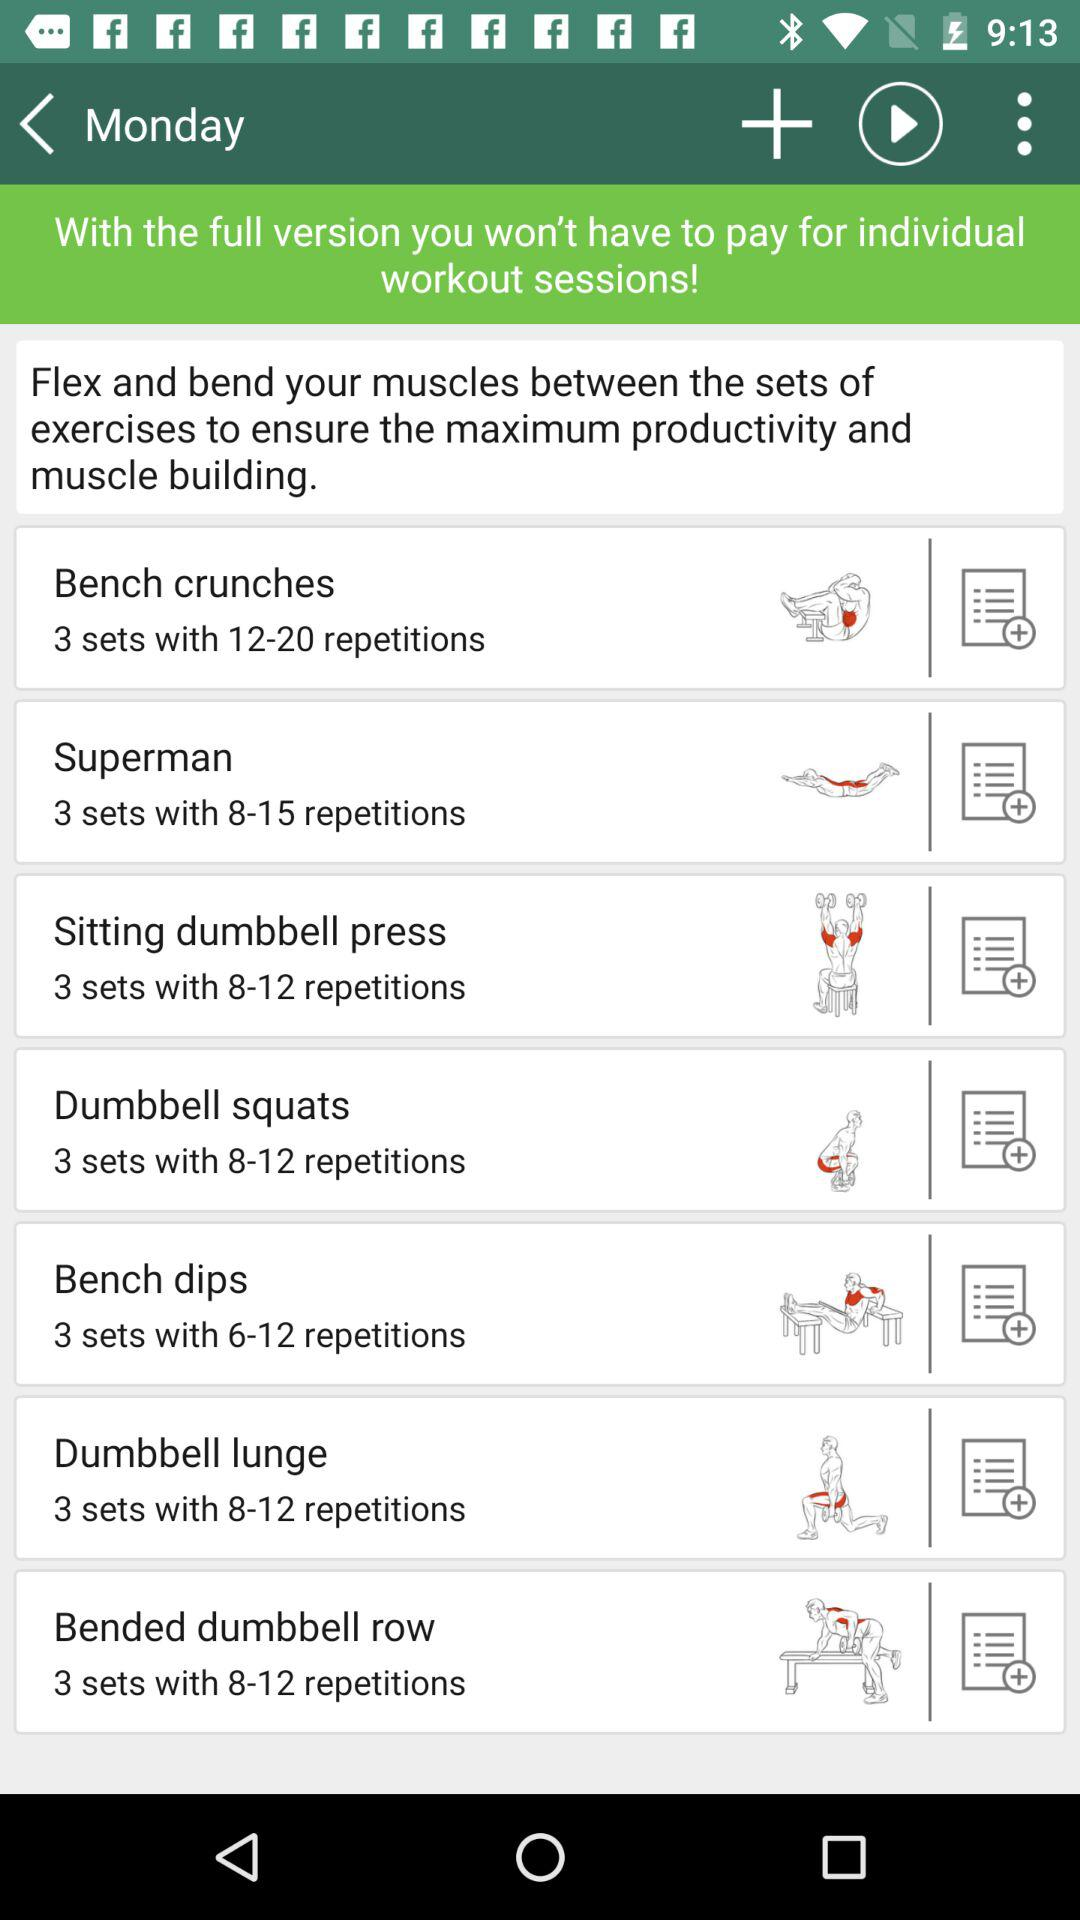What is the count of sets for the "Bench dip"? The count is "3 sets with 6-12 repetitions". 